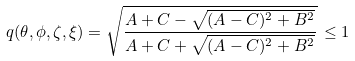Convert formula to latex. <formula><loc_0><loc_0><loc_500><loc_500>q ( \theta , \phi , \zeta , \xi ) = \sqrt { \frac { A + C - \sqrt { ( A - C ) ^ { 2 } + B ^ { 2 } } } { A + C + \sqrt { ( A - C ) ^ { 2 } + B ^ { 2 } } } } \, \leq 1</formula> 